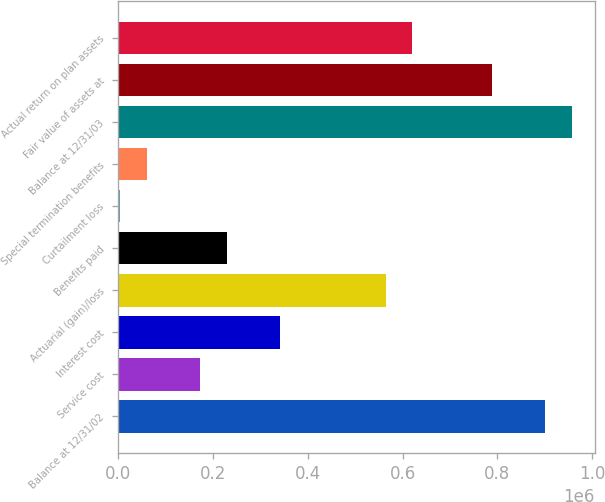<chart> <loc_0><loc_0><loc_500><loc_500><bar_chart><fcel>Balance at 12/31/02<fcel>Service cost<fcel>Interest cost<fcel>Actuarial (gain)/loss<fcel>Benefits paid<fcel>Curtailment loss<fcel>Special termination benefits<fcel>Balance at 12/31/03<fcel>Fair value of assets at<fcel>Actual return on plan assets<nl><fcel>901066<fcel>172931<fcel>340962<fcel>565004<fcel>228942<fcel>4900<fcel>60910.4<fcel>957077<fcel>789046<fcel>621014<nl></chart> 